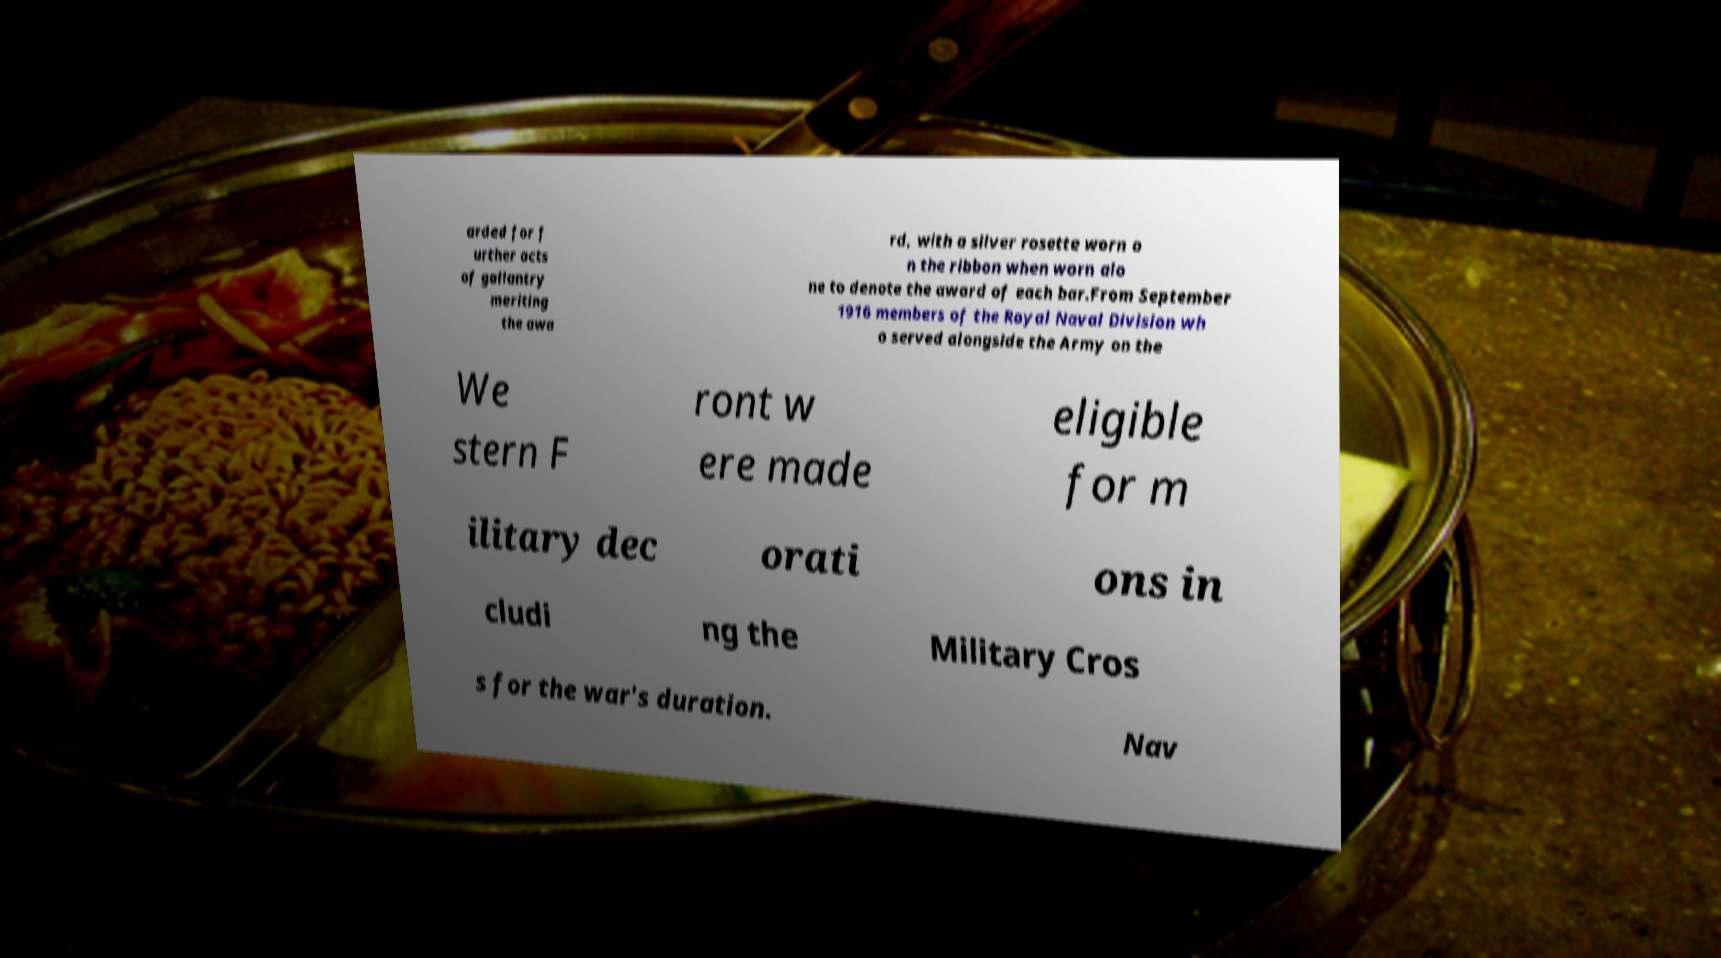Could you extract and type out the text from this image? arded for f urther acts of gallantry meriting the awa rd, with a silver rosette worn o n the ribbon when worn alo ne to denote the award of each bar.From September 1916 members of the Royal Naval Division wh o served alongside the Army on the We stern F ront w ere made eligible for m ilitary dec orati ons in cludi ng the Military Cros s for the war's duration. Nav 